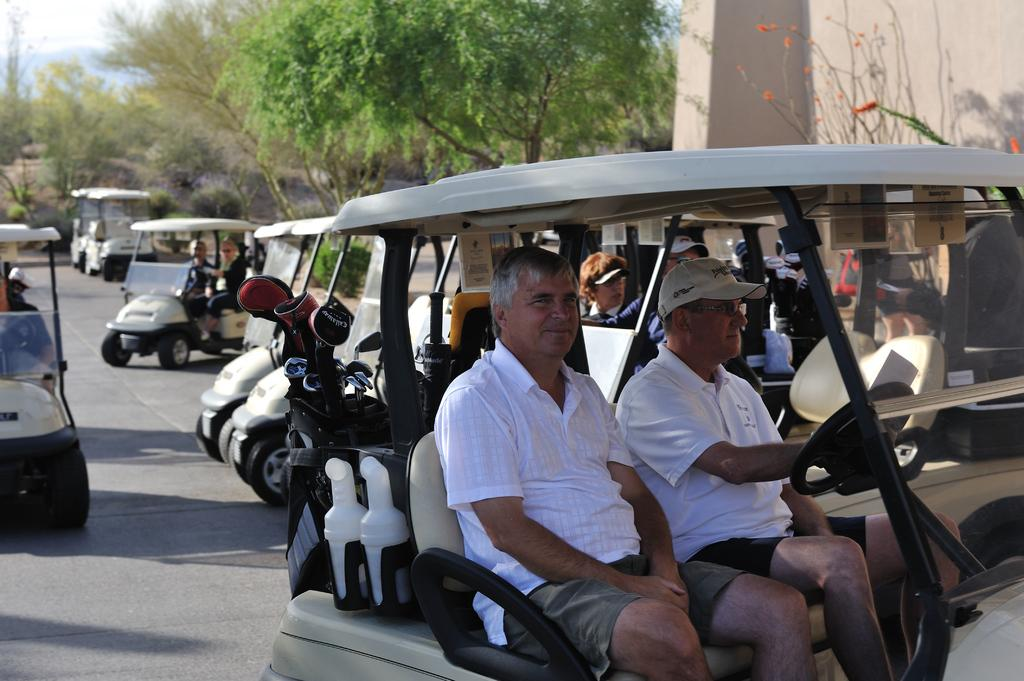How many persons can be seen in the image? There are persons in the image. What else is present in the image besides the persons? There are vehicles in the image. Are any of the persons inside the vehicles? Some persons are inside the vehicles. What can be seen at the top of the image? There are trees at the top of the image. What architectural feature is visible in the top right of the image? There is a wall in the top right of the image. Reasoning: Let's think step by identifying the main subjects and objects in the image based on the provided facts. We then formulate questions that focus on the location and characteristics of these subjects and objects, ensuring that each question can be answered definitively with the information given. We avoid yes/no questions and ensure that the language is simple and clear. Absurd Question/Answer: What type of arithmetic problem is being solved by the persons in the image? There is no indication of any arithmetic problem being solved in the image. What sound might the alarm make in the image? There is no alarm present in the image. Is there a knife visible in the image? There is no knife present in the image. 